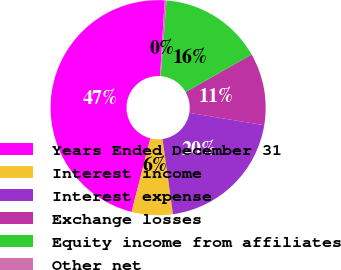Convert chart. <chart><loc_0><loc_0><loc_500><loc_500><pie_chart><fcel>Years Ended December 31<fcel>Interest income<fcel>Interest expense<fcel>Exchange losses<fcel>Equity income from affiliates<fcel>Other net<nl><fcel>47.02%<fcel>6.17%<fcel>20.19%<fcel>10.84%<fcel>15.51%<fcel>0.28%<nl></chart> 